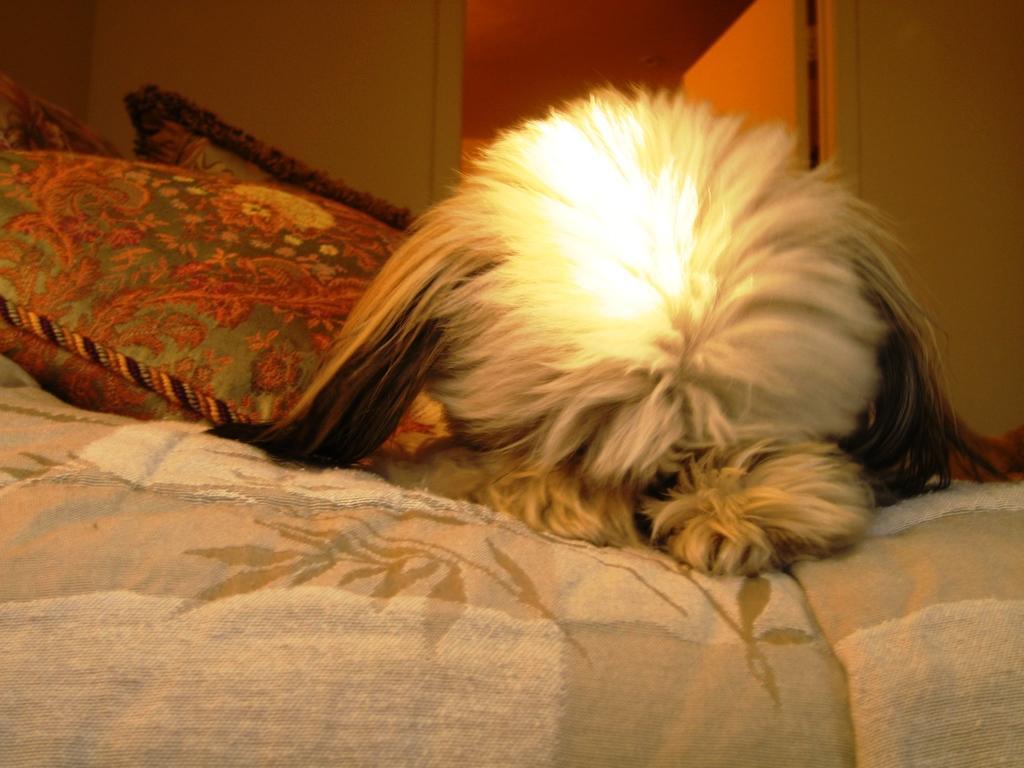Please provide a concise description of this image. In this picture there is an animal lying on the bed and beside that animal there are some pillows. In the background there is a wall, door. 